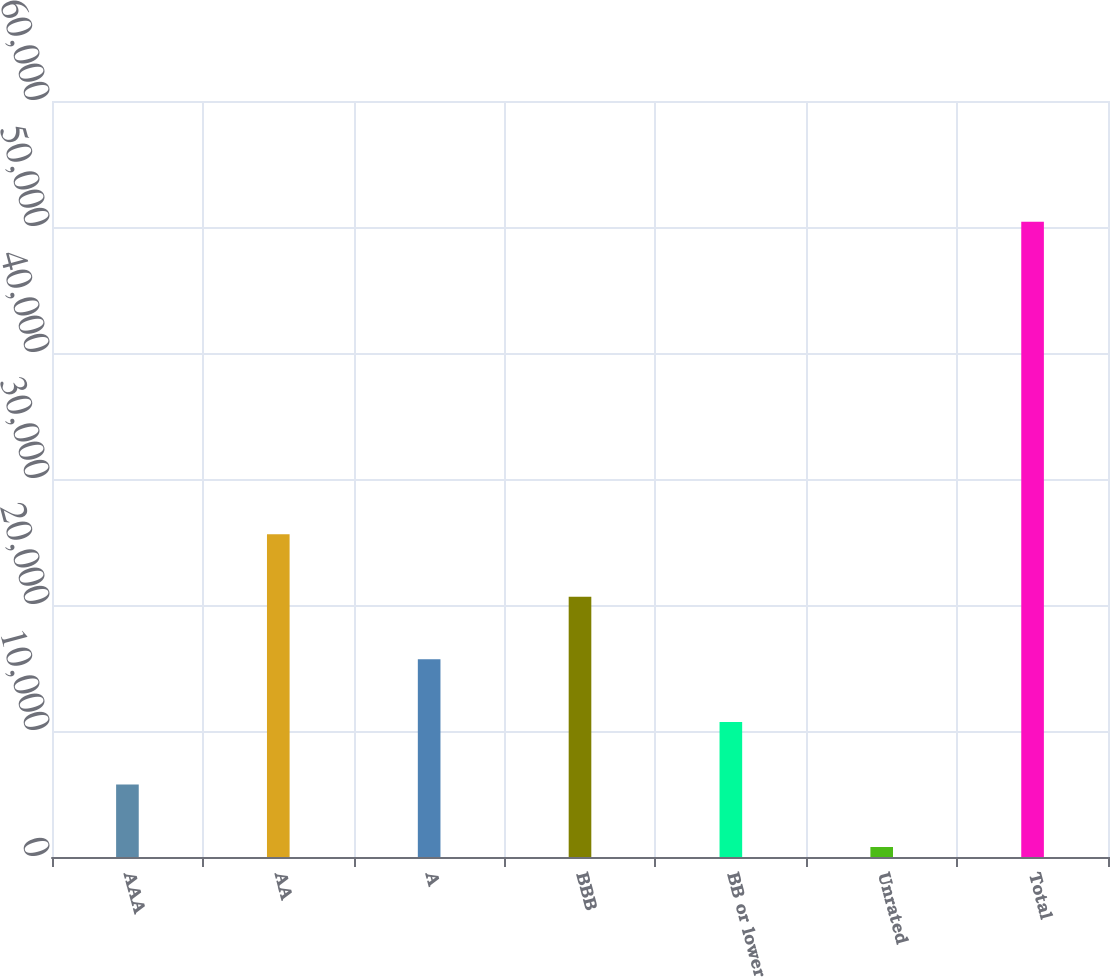Convert chart to OTSL. <chart><loc_0><loc_0><loc_500><loc_500><bar_chart><fcel>AAA<fcel>AA<fcel>A<fcel>BBB<fcel>BB or lower<fcel>Unrated<fcel>Total<nl><fcel>5759<fcel>25611<fcel>15685<fcel>20648<fcel>10722<fcel>796<fcel>50426<nl></chart> 